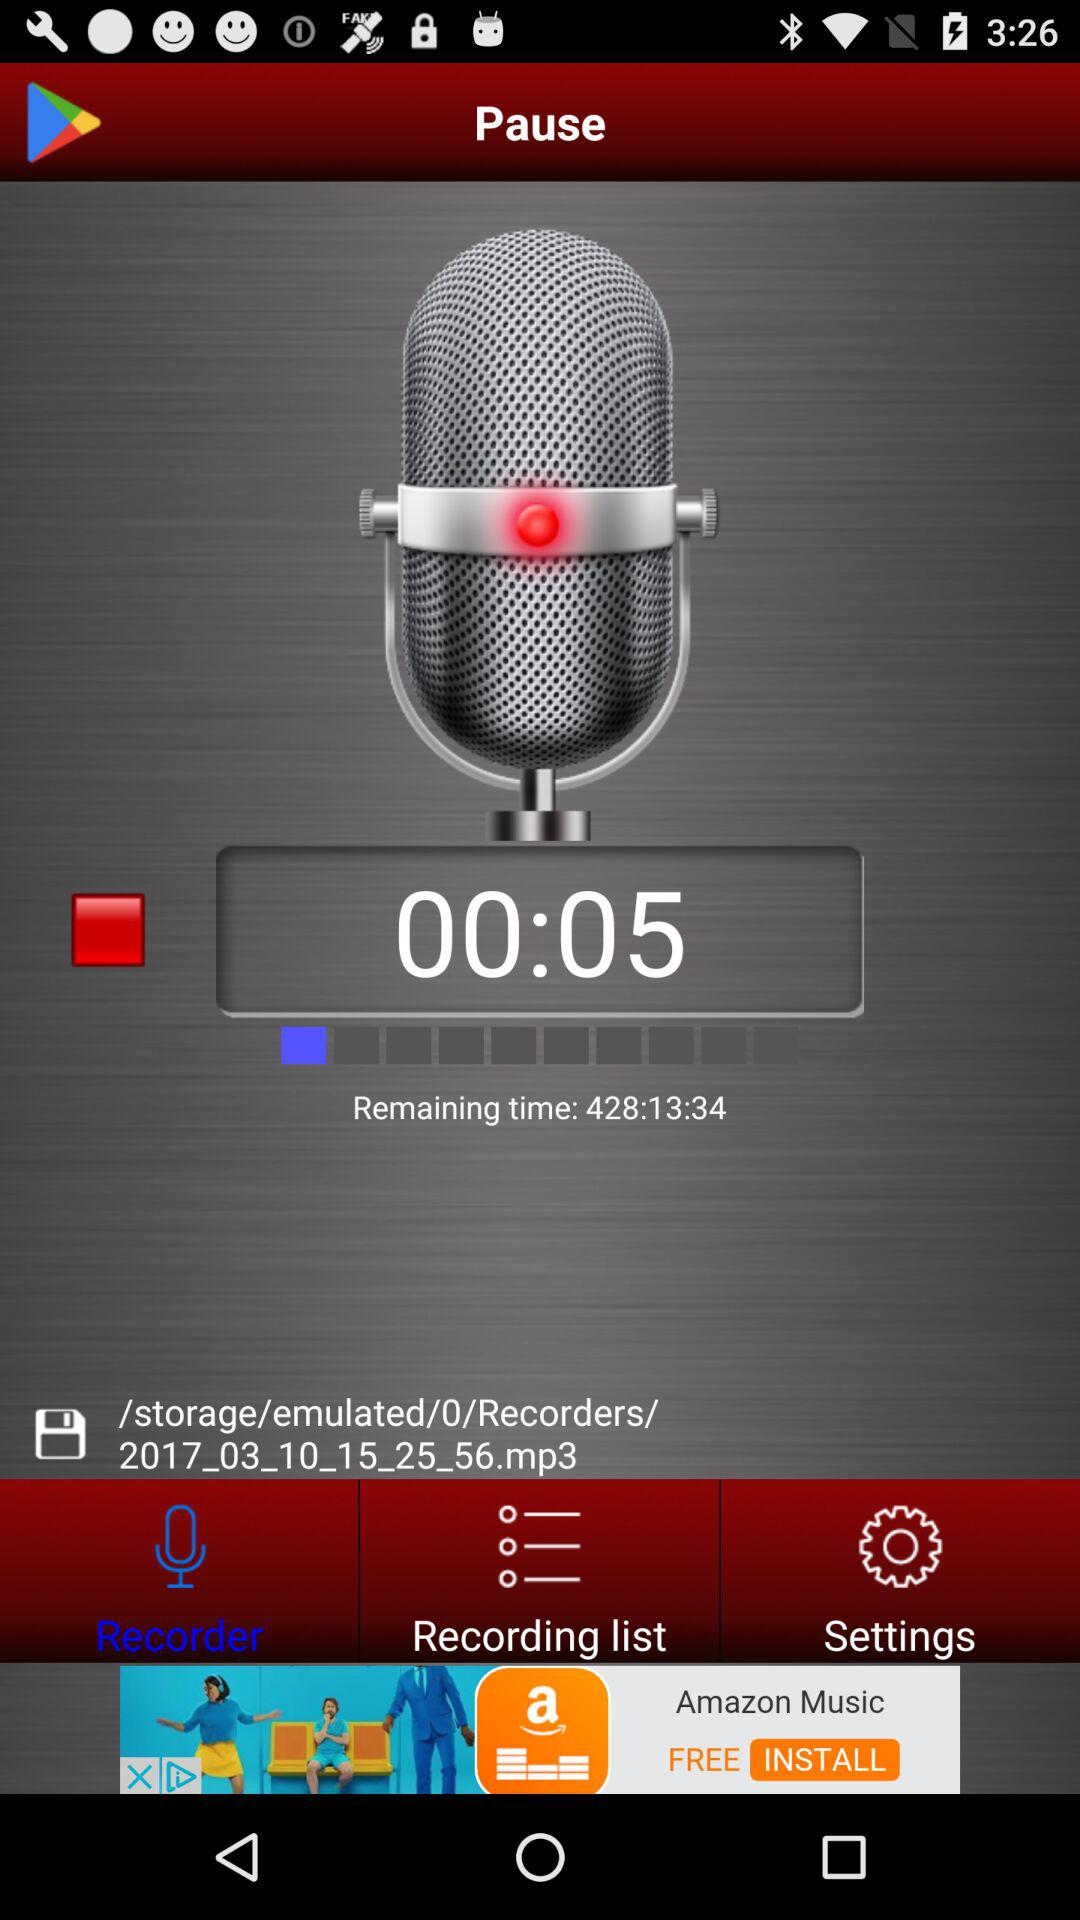What is the current time of the recording? The current time of the recording is 5 seconds. 